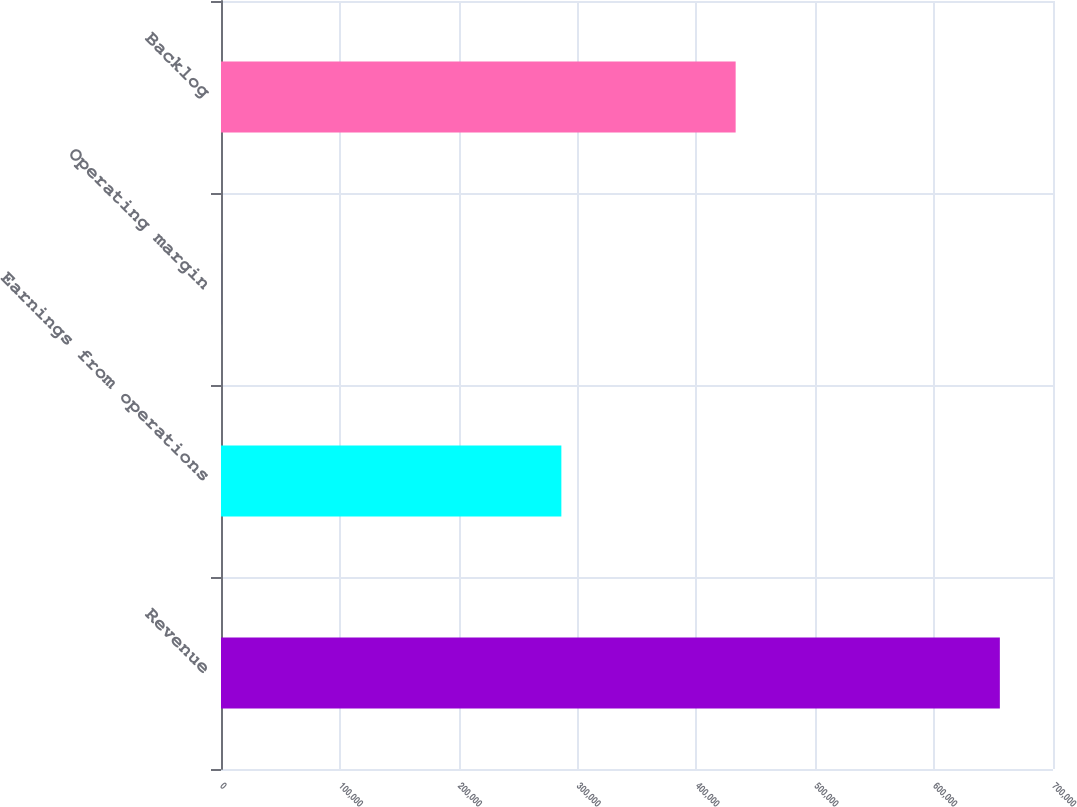<chart> <loc_0><loc_0><loc_500><loc_500><bar_chart><fcel>Revenue<fcel>Earnings from operations<fcel>Operating margin<fcel>Backlog<nl><fcel>655282<fcel>286361<fcel>43.7<fcel>433000<nl></chart> 